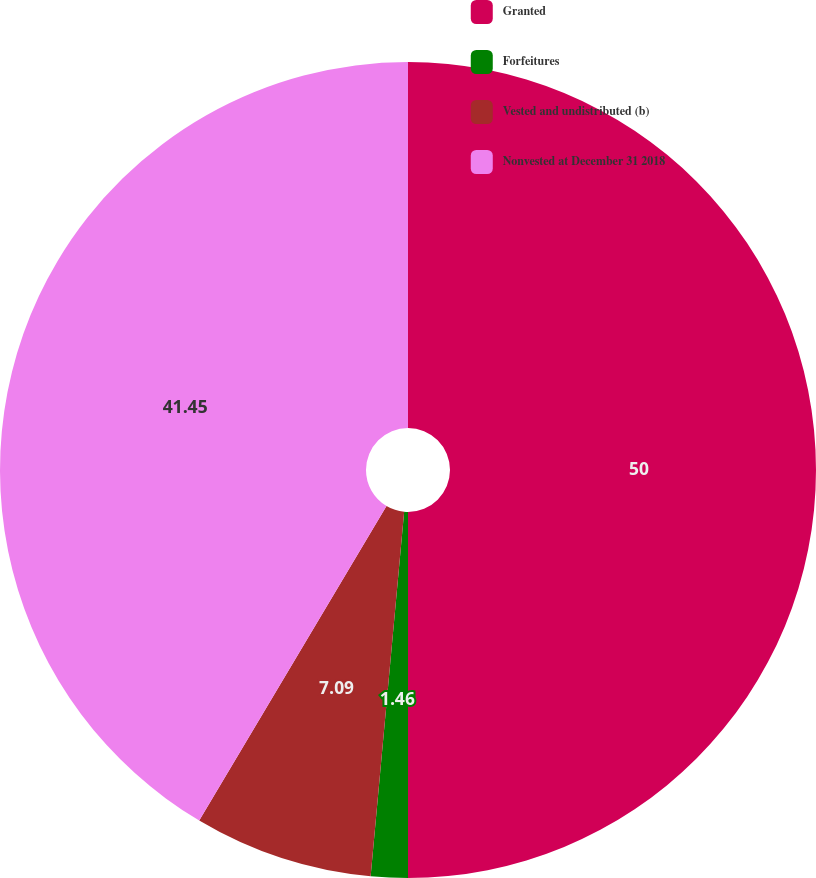Convert chart. <chart><loc_0><loc_0><loc_500><loc_500><pie_chart><fcel>Granted<fcel>Forfeitures<fcel>Vested and undistributed (b)<fcel>Nonvested at December 31 2018<nl><fcel>50.0%<fcel>1.46%<fcel>7.09%<fcel>41.45%<nl></chart> 